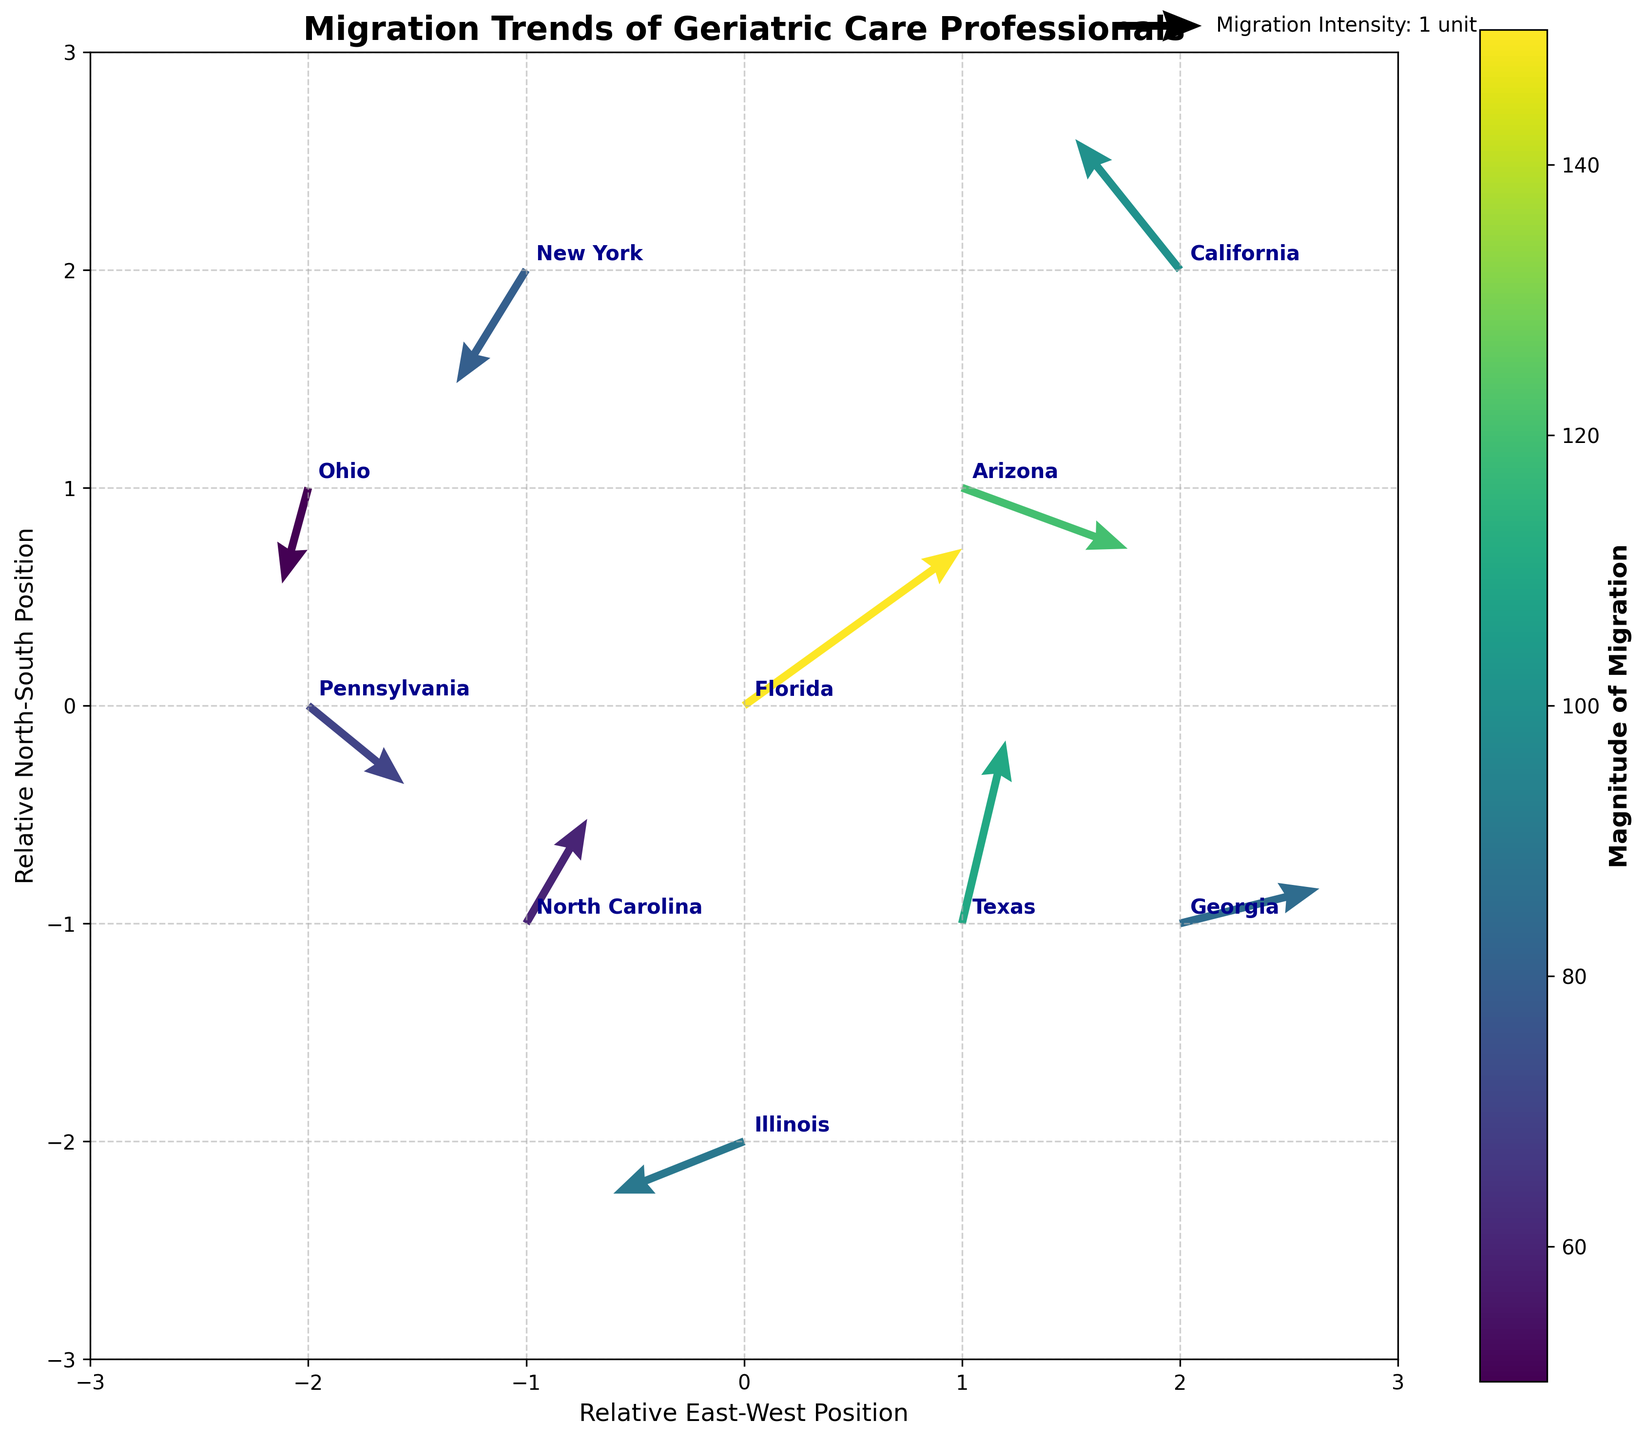What's the title of the plot? The title is located at the top center of the plot. Reading it reveals the title is "Migration Trends of Geriatric Care Professionals".
Answer: Migration Trends of Geriatric Care Professionals How many states are represented in the plot? Each arrow in the quiver plot represents a state. By counting the number of unique arrows, we can determine that there are 10 states represented.
Answer: 10 Which state has the highest magnitude of migration? The color and length of the arrows represent the magnitude of migration, with Florida having the darkest shade and longest arrow, indicating a magnitude of 150.
Answer: Florida Which state has the lowest magnitude of migration? The color and length of the arrows represent the magnitude of migration, with Ohio having the lightest shade and shortest arrow, indicating a magnitude of 50.
Answer: Ohio What is the migration direction for North Carolina? The arrow for North Carolina originates from coordinates (-1, -1) and points in the (0.7, 1.2) direction, meaning it is moving north-east.
Answer: North-east Compare the movement direction between California and New York. California's arrow points from (2,2) to (-1.2,1.5), indicating a southwest direction. New York's arrow points from (-1,2) to (-0.8,-1.3), indicating a southeast direction.
Answer: California moves southwest, New York moves southeast Which state shows the strongest southward migration trend? Examining the y components (V) of the arrows, New York has a direction value of -1.3, which is the most negative and shows the strongest southward migration trend.
Answer: New York How does the migration magnitude of Texas compare to that of Illinois? The magnitude of migration for Texas is 110, while that of Illinois is 90. Texas has a higher migration magnitude.
Answer: Texas has a higher migration magnitude What direction is the migration trend for Pennsylvania? The arrow for Pennsylvania originates from coordinates (-2, 0) and points in the (1.1, -0.9) direction, indicating a southeast movement.
Answer: Southeast Identify a state with a westward migration component. Illinois has an x component (U) of -1.5, indicating a westward migration direction.
Answer: Illinois 